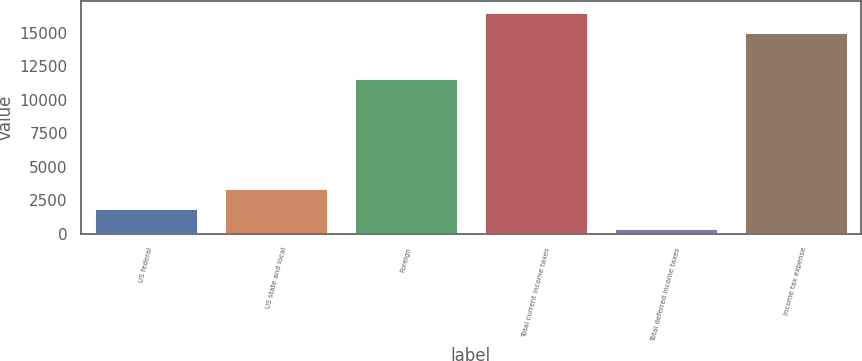Convert chart. <chart><loc_0><loc_0><loc_500><loc_500><bar_chart><fcel>US federal<fcel>US state and local<fcel>Foreign<fcel>Total current income taxes<fcel>Total deferred income taxes<fcel>Income tax expense<nl><fcel>1895.6<fcel>3400.2<fcel>11616<fcel>16550.6<fcel>391<fcel>15046<nl></chart> 